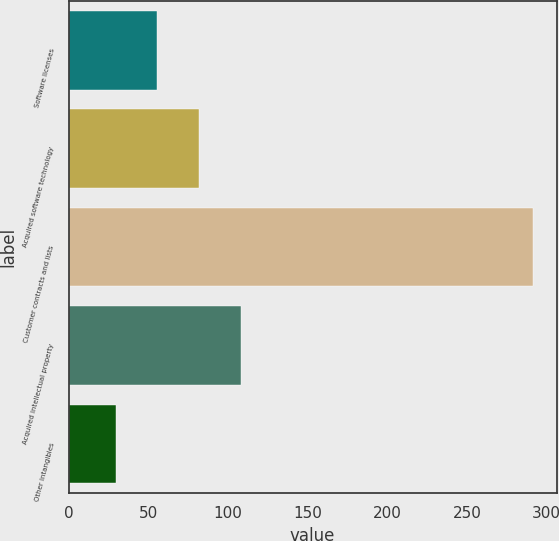Convert chart to OTSL. <chart><loc_0><loc_0><loc_500><loc_500><bar_chart><fcel>Software licenses<fcel>Acquired software technology<fcel>Customer contracts and lists<fcel>Acquired intellectual property<fcel>Other intangibles<nl><fcel>55.72<fcel>81.94<fcel>291.7<fcel>108.16<fcel>29.5<nl></chart> 